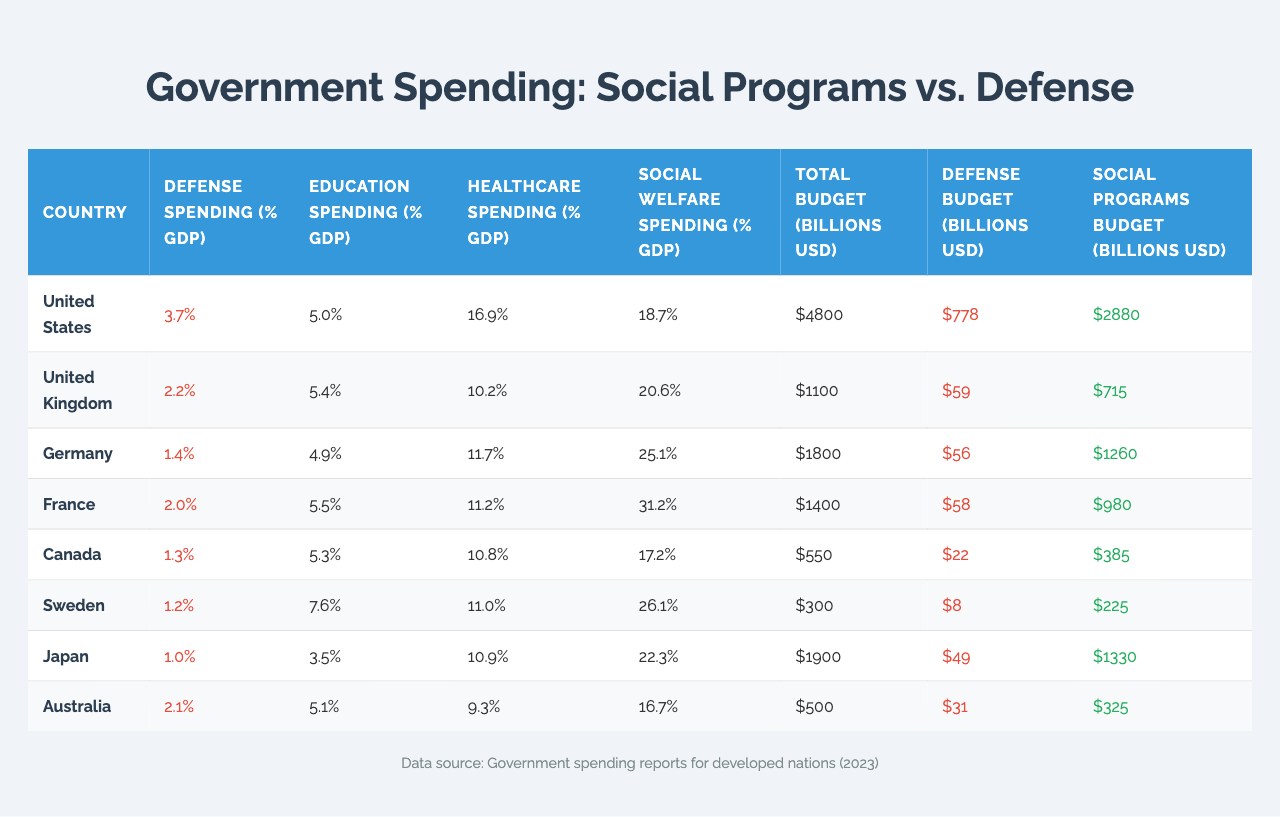What is the defense spending as a percentage of GDP for Germany? In the table, I can find the row for Germany, where the value listed under "Defense Spending (% GDP)" is 1.4%.
Answer: 1.4% Which country has the highest social welfare spending as a percentage of GDP? By checking each country's social welfare spending percentage in the table, I see that France has the highest value at 31.2%.
Answer: France What is the total budget in billions USD for the United Kingdom? Looking at the United Kingdom row in the table, the total budget is shown as 1100 billion USD.
Answer: 1100 billion USD Compare the social programs budget between the United States and Australia. The social programs budget for the United States is 2880 billion USD and for Australia is 325 billion USD. The difference is 2880 - 325 = 2555 billion USD, indicating the US spends significantly more.
Answer: 2555 billion USD What percentage of GDP does Japan allocate to healthcare? In the Japan row of the table, the healthcare spending percentage is listed as 10.9%.
Answer: 10.9% Is the defense budget of Sweden higher than that of Canada? The defense budget for Sweden is 8 billion USD and for Canada is 22 billion USD. Therefore, no, Sweden does not have a higher defense budget than Canada.
Answer: No What is the average social welfare spending percentage across these countries? To find the average, I sum the social welfare spending percentages: (18.7 + 20.6 + 25.1 + 31.2 + 17.2 + 26.1 + 22.3 + 16.7) =  178.9, then divide by 8, resulting in an average of 22.36%.
Answer: 22.36% Which country allocates less than 2% of their GDP to defense spending? By reviewing the defense spending percentage for each country, I see that Germany (1.4%), Canada (1.3%), Sweden (1.2%), and Japan (1.0%) all allocate less than 2%.
Answer: Germany, Canada, Sweden, Japan Calculate the difference in total budget between the United States and France. The total budget for the United States is 4800 billion USD and for France is 1400 billion USD. The difference is 4800 - 1400 = 3400 billion USD, indicating a significantly higher budget for the US.
Answer: 3400 billion USD Do all listed countries have social programs budgets exceeding their defense budgets? By comparing the social programs and defense budgets for each country, I find that yes, all countries listed do have social programs budgets that exceed their defense budgets.
Answer: Yes 